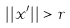<formula> <loc_0><loc_0><loc_500><loc_500>| | x ^ { \prime } | | > r</formula> 